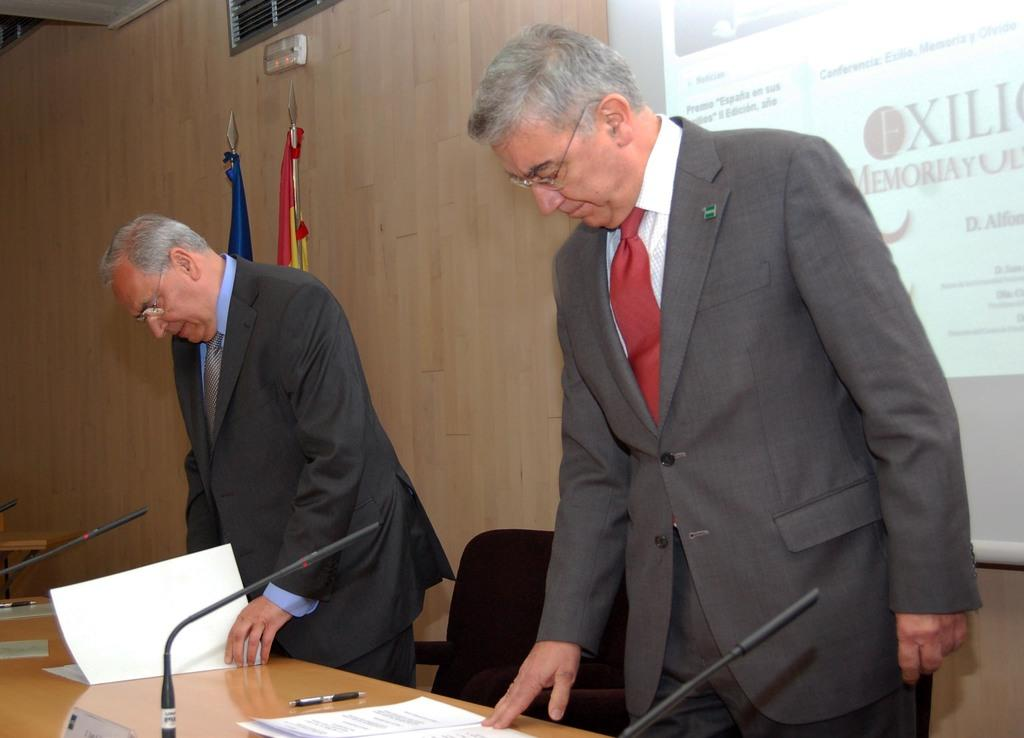What are the two men in the image doing? The two men are standing. What type of furniture is visible in the image? There are chairs in the image. What device is present for amplifying sound or recording? A microphone is present in the image. What stationery items can be seen in the image? There is a pen and paper in the image. What is used for displaying information or visuals in the image? There is a screen in the image. What type of honey is being served on the chairs in the image? There is no honey present in the image; the chairs are empty. What metal object is being used to draw a square in the image? There is no metal object or drawing of a square present in the image. 